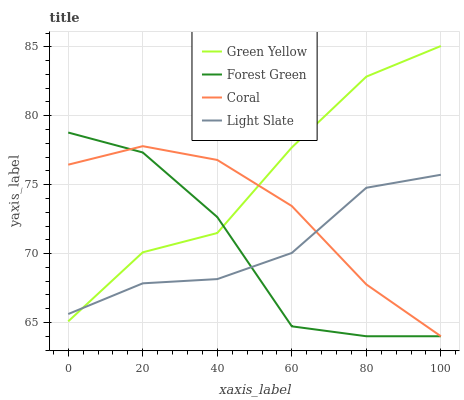Does Forest Green have the minimum area under the curve?
Answer yes or no. Yes. Does Green Yellow have the maximum area under the curve?
Answer yes or no. Yes. Does Green Yellow have the minimum area under the curve?
Answer yes or no. No. Does Forest Green have the maximum area under the curve?
Answer yes or no. No. Is Coral the smoothest?
Answer yes or no. Yes. Is Forest Green the roughest?
Answer yes or no. Yes. Is Green Yellow the smoothest?
Answer yes or no. No. Is Green Yellow the roughest?
Answer yes or no. No. Does Green Yellow have the lowest value?
Answer yes or no. No. Does Green Yellow have the highest value?
Answer yes or no. Yes. Does Forest Green have the highest value?
Answer yes or no. No. Does Coral intersect Forest Green?
Answer yes or no. Yes. Is Coral less than Forest Green?
Answer yes or no. No. Is Coral greater than Forest Green?
Answer yes or no. No. 